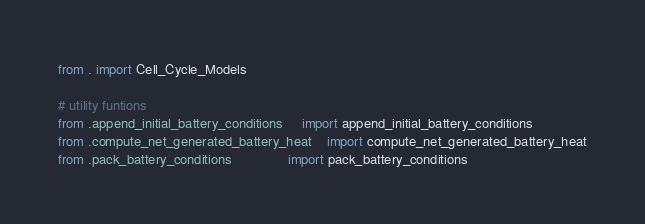Convert code to text. <code><loc_0><loc_0><loc_500><loc_500><_Python_>from . import Cell_Cycle_Models

# utility funtions 
from .append_initial_battery_conditions     import append_initial_battery_conditions
from .compute_net_generated_battery_heat    import compute_net_generated_battery_heat
from .pack_battery_conditions               import pack_battery_conditions</code> 